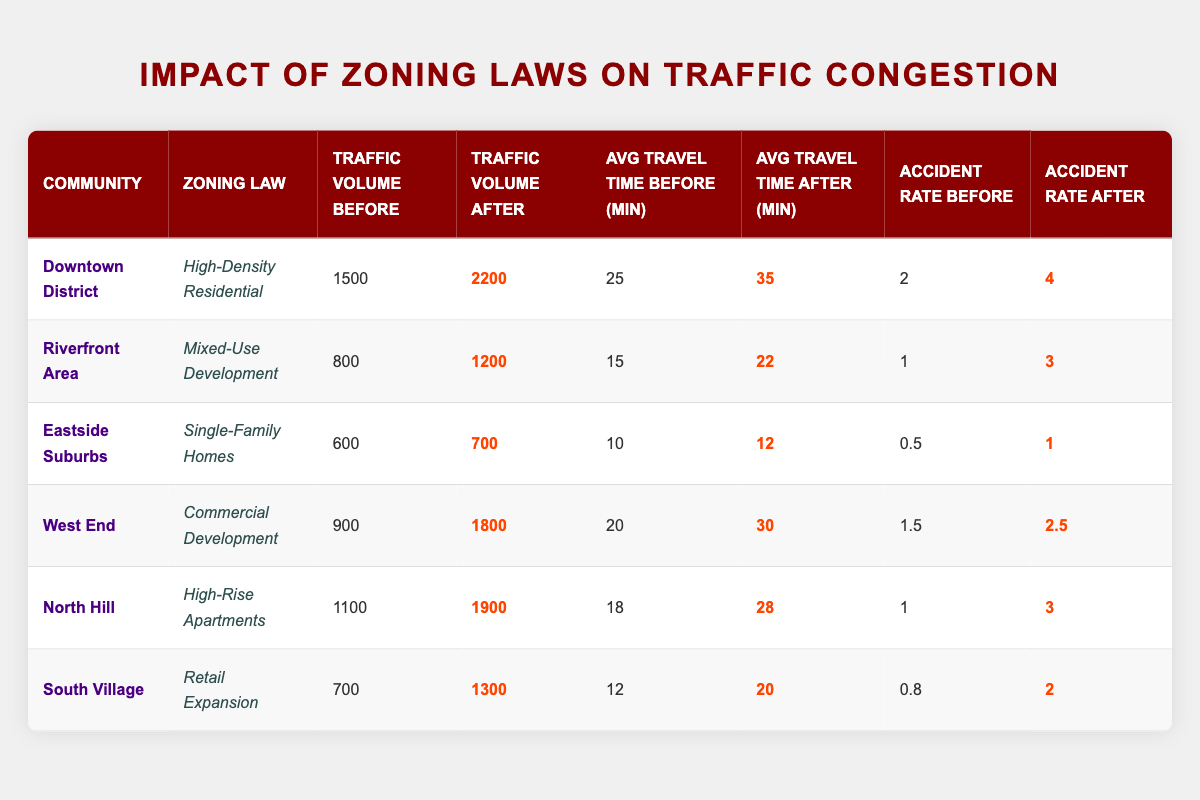What is the traffic volume in the Downtown District after the zoning change? The table indicates that the traffic volume after the zoning change in the Downtown District is 2200.
Answer: 2200 How many communities experienced an increase in the average travel time after zoning laws were enacted? By examining the table, we see that the following communities had an increase in average travel time after the changes: Downtown District (from 25 to 35), Riverfront Area (from 15 to 22), West End (from 20 to 30), North Hill (from 18 to 28), and South Village (from 12 to 20). Therefore, 5 communities experienced this increase.
Answer: 5 What was the accident rate in the Riverfront Area before the zoning change? According to the table, the accident rate in the Riverfront Area before the zoning change was 1.
Answer: 1 Did any community see a decrease in traffic volume after zoning laws were applied? The table shows that all communities experienced an increase in traffic volume after the zoning changes. Therefore, the answer is no, none had a decrease.
Answer: No What is the difference in traffic volume before and after for the West End community? For the West End community, the traffic volume before was 900 and after was 1800. The difference is calculated as 1800 - 900 = 900.
Answer: 900 Which community had the highest increase in accident rate after the zoning change? In the table, we can see that the Downtown District had an accident rate increase from 2 to 4 (increase of 2), Riverfront Area from 1 to 3 (increase of 2), West End from 1.5 to 2.5 (increase of 1), and North Hill from 1 to 3 (increase of 2). The Eastside Suburbs had the smallest increase. Thus the highest increase is 2 for Downtown District, Riverfront Area, and North Hill.
Answer: Downtown District, Riverfront Area, North Hill What is the average accident rate before the zoning changes across all communities? To find the average, we sum the accident rates before: 2 + 1 + 0.5 + 1.5 + 1 + 0.8 = 7.8. Since there are 6 communities, we divide by 6: 7.8 / 6 = 1.3.
Answer: 1.3 Is the average travel time after for Eastside Suburbs less than 20 minutes? The table shows that the average travel time after the zoning change for Eastside Suburbs is 12 minutes, which is indeed less than 20 minutes.
Answer: Yes Which community shows the most significant increase in average travel time? By analyzing the changes in average travel time, Downtown District had an increase from 25 to 35 (10 minutes), Riverfront Area from 15 to 22 (7 minutes), West End from 20 to 30 (10 minutes), North Hill from 18 to 28 (10 minutes), and South Village from 12 to 20 (8 minutes). Thus, the highest increase was tied between Downtown District, West End, and North Hill, each with a 10-minute increase.
Answer: Downtown District, West End, North Hill 